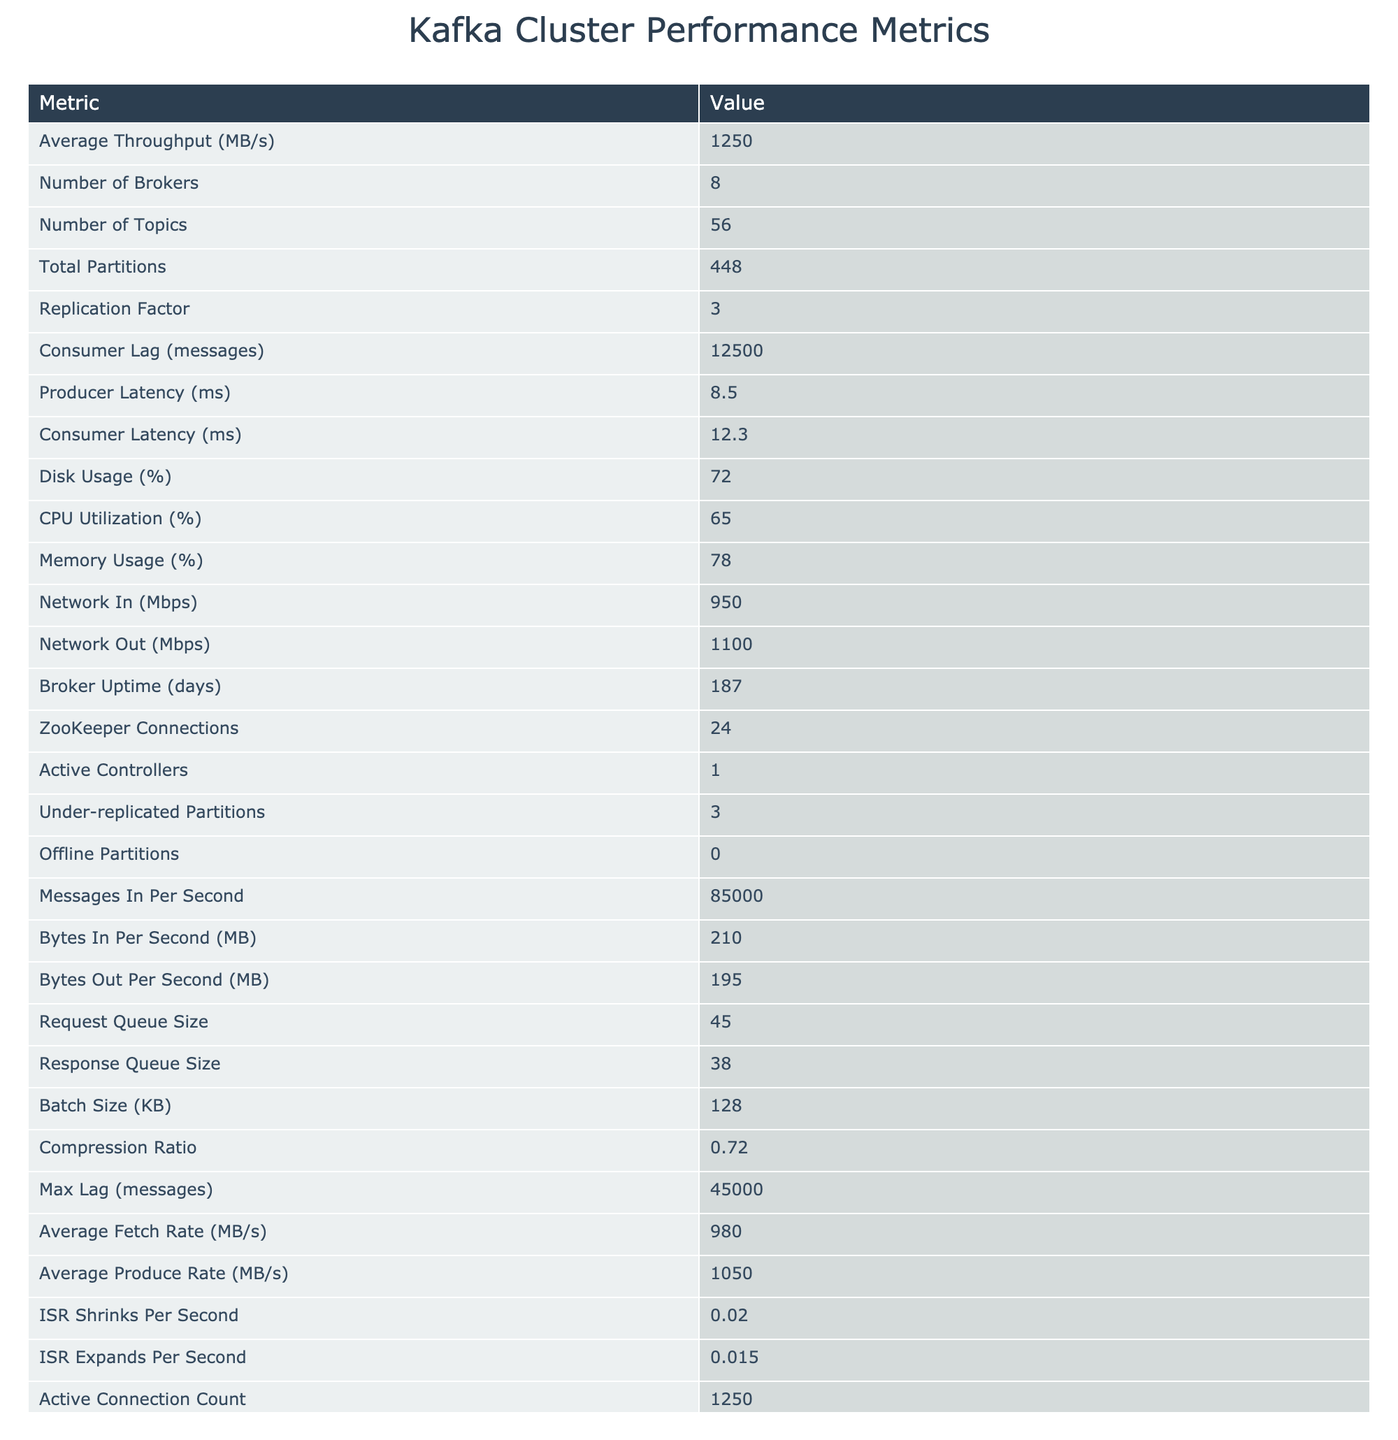What is the average throughput of the Kafka cluster? The table lists the "Average Throughput" metric explicitly as 1250 MB/s.
Answer: 1250 MB/s How many topics are there in the Kafka cluster? The number of topics is stated as 56 in the table.
Answer: 56 What is the replication factor for the Kafka cluster? Referring to the table, the replication factor is shown as 3.
Answer: 3 What is the total number of partitions in the Kafka cluster? The total number of partitions is directly given in the table as 448.
Answer: 448 What is the consumer lag in messages? According to the table, the consumer lag is noted as 12500 messages.
Answer: 12500 messages Is there any offline partition in the cluster? The table shows "Offline Partitions" as 0, indicating there are no offline partitions.
Answer: No What is the average producer latency in milliseconds? The average producer latency is specified in the table as 8.5 ms.
Answer: 8.5 ms What is the CPU utilization percentage? The CPU utilization percentage is recorded as 65% in the table.
Answer: 65% How does the number of brokers compare to the number of active controllers? The number of brokers is 8 while there is 1 active controller, indicating multiple brokers are available for a single active controller.
Answer: 8 brokers, 1 active controller What is the difference between the average fetch rate and the average produce rate? The average fetch rate is 980 MB/s and the average produce rate is 1050 MB/s. The difference is calculated as 1050 - 980 = 70 MB/s.
Answer: 70 MB/s What is the total network usage in Mbps for both incoming and outgoing? The incoming network usage is 950 Mbps and outgoing is 1100 Mbps. Total usage = 950 + 1100 = 2050 Mbps.
Answer: 2050 Mbps What percentage of disk usage is reported? The table indicates that the disk usage is at 72%.
Answer: 72% Is the average produce rate greater than the average fetch rate? The average produce rate is 1050 MB/s while the average fetch rate is 980 MB/s. Since 1050 is greater than 980, this statement is true.
Answer: Yes How many under-replicated partitions does the cluster have? The table lists 3 under-replicated partitions, which can be found under the corresponding metric.
Answer: 3 What is the average latency discrepancy between producers and consumers? Producer latency is 8.5 ms and consumer latency is 12.3 ms. The discrepancy is calculated as 12.3 - 8.5 = 3.8 ms.
Answer: 3.8 ms If the maximum lag is 45000 messages and consumer lag is 12500 messages, what is the remaining lag? The remaining lag is calculated by subtracting consumer lag from the maximum lag: 45000 - 12500 = 32500 messages.
Answer: 32500 messages 